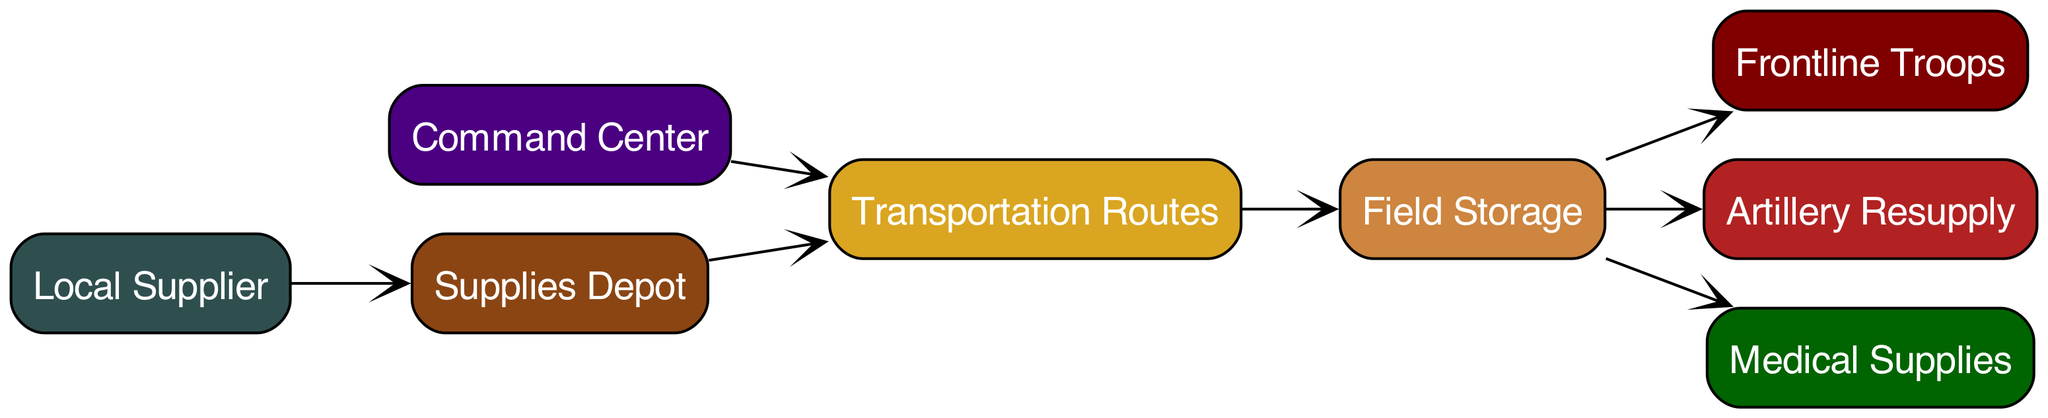What is the total number of nodes in the diagram? The diagram lists eight distinct entities representing aspects of supply line logistics: Supplies Depot, Transportation Routes, Local Supplier, Field Storage, Frontline Troops, Artillery Resupply, Medical Supplies, and Command Center. Counting these gives a total of eight nodes.
Answer: 8 What resource does the Local Supplier provide? The diagram shows an edge originating from the Local Supplier that points to the Supplies Depot. This indicates that the Local Supplier is responsible for providing supplies to the Supplies Depot.
Answer: Supplies Which node is responsible for transporting supplies to the Frontline Troops? To understand the flow, we see that supplies move from the Field Storage to the Frontline Troops. The Field Storage node serves as an intermediary for supplies being moved to the troops at the front lines.
Answer: Field Storage How many edges are connected to the Field Storage node? The Field Storage node has three outgoing edges: one to Frontline Troops, one to Artillery Resupply, and one to Medical Supplies. By counting these edges, we find that there are three connections.
Answer: 3 What two nodes are directly connected to the Transportation Routes node? Analyzing the edges, we note that the Transportation Routes node connects to two nodes: Supplies Depot and Command Center. This indicates the routes lead to both the storage depot and the command center.
Answer: Supplies Depot, Command Center Which node is at the end of the flow from the Field Storage node? The edges show that the Field Storage is a source to multiple nodes, including Frontline Troops for direct battle support. Tracing this onwards, we identify that Frontline Troops is the final recipient of the supplies.
Answer: Frontline Troops What role does the Command Center play in relation to the Transportation Routes? The Command Center has a direct edge leading to the Transportation Routes, indicating that it plays a crucial role in managing or overseeing these transportation paths and logistics during operations.
Answer: Management What is the flow of resources from the Local Supplier to the Frontline Troops? Starting from the Local Supplier, resources move to the Supplies Depot, then to Transportation Routes, followed by Field Storage, and finally reaching the Frontline Troops. This pathway outlines the method and connections involved in supply delivery.
Answer: Local Supplier to Supplies Depot to Transportation Routes to Field Storage to Frontline Troops 